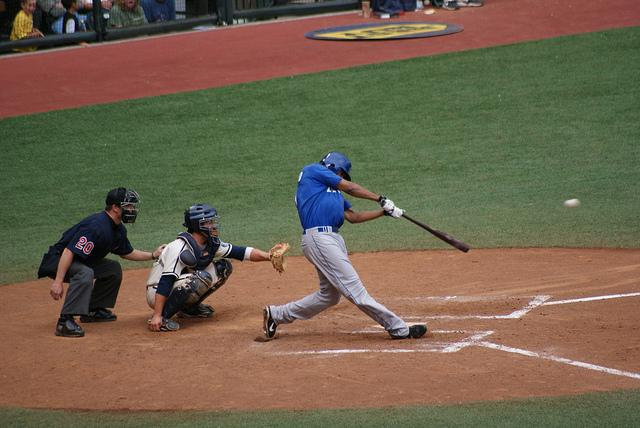What is the gear called that the umpire is wearing on his face? mask 